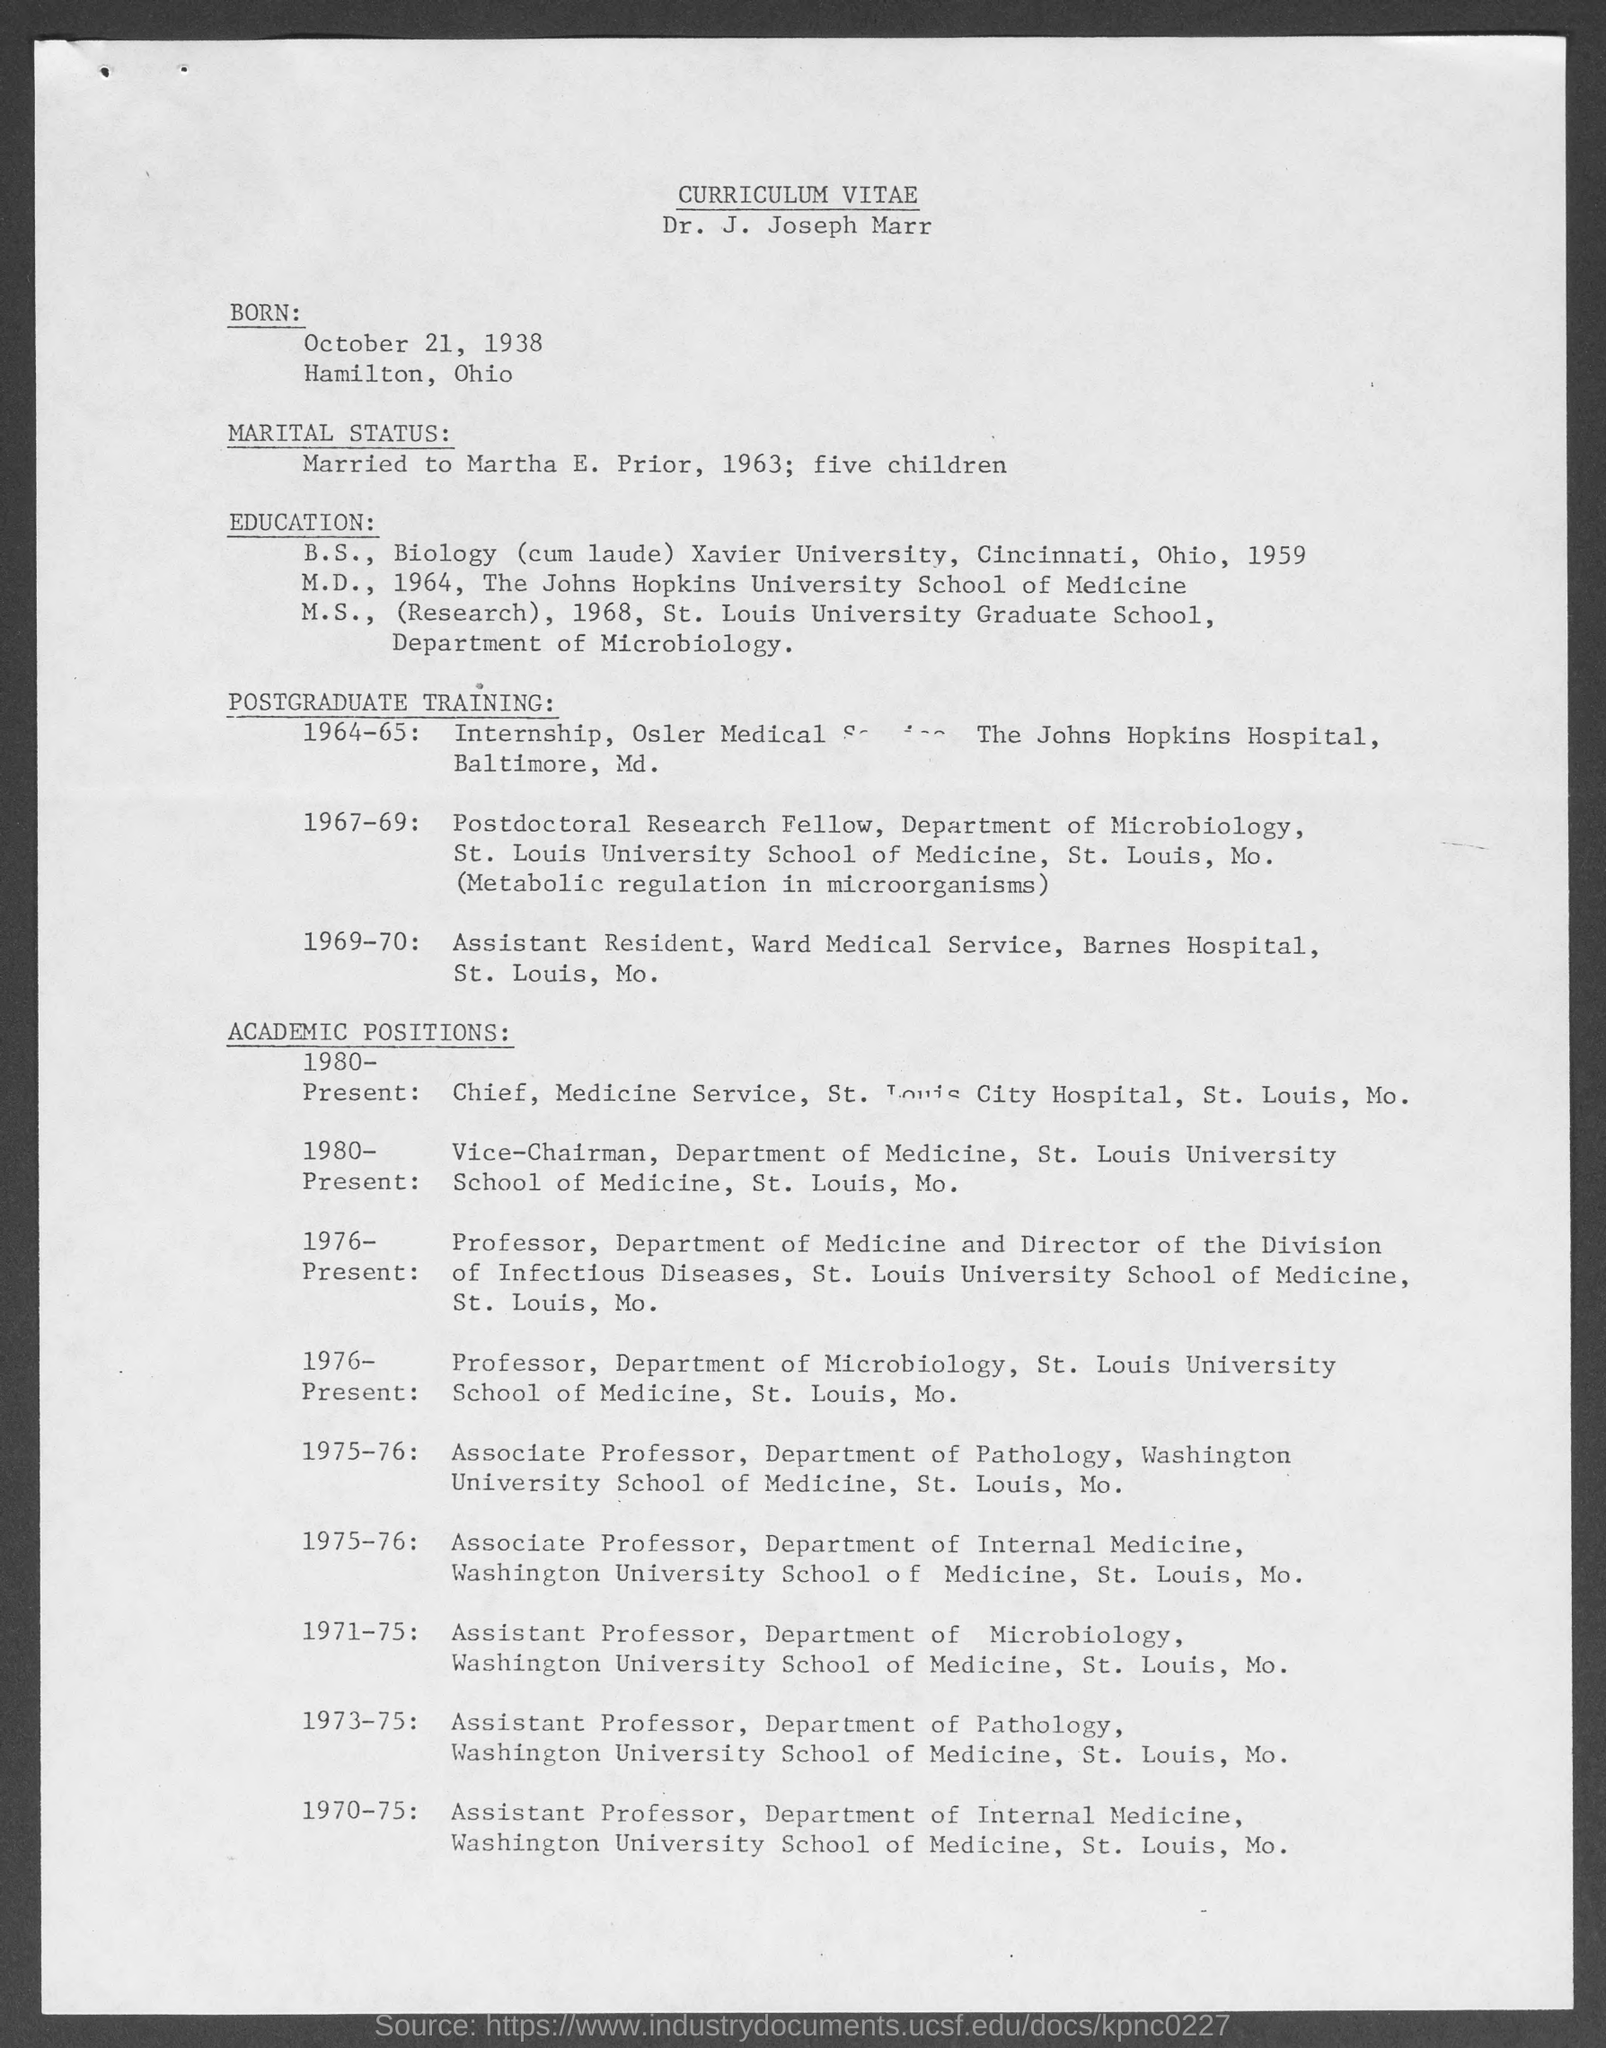What is the title at top of the page?
Make the answer very short. Curriculum vitae. In which year did dr. j. joseph marr complete is b.s. ?
Make the answer very short. 1959. In which year did dr. j. joseph marr complete his m.d.?
Provide a succinct answer. 1964. In which year did dr. j. joseph marr complete his m.s.?
Offer a very short reply. 1968. 